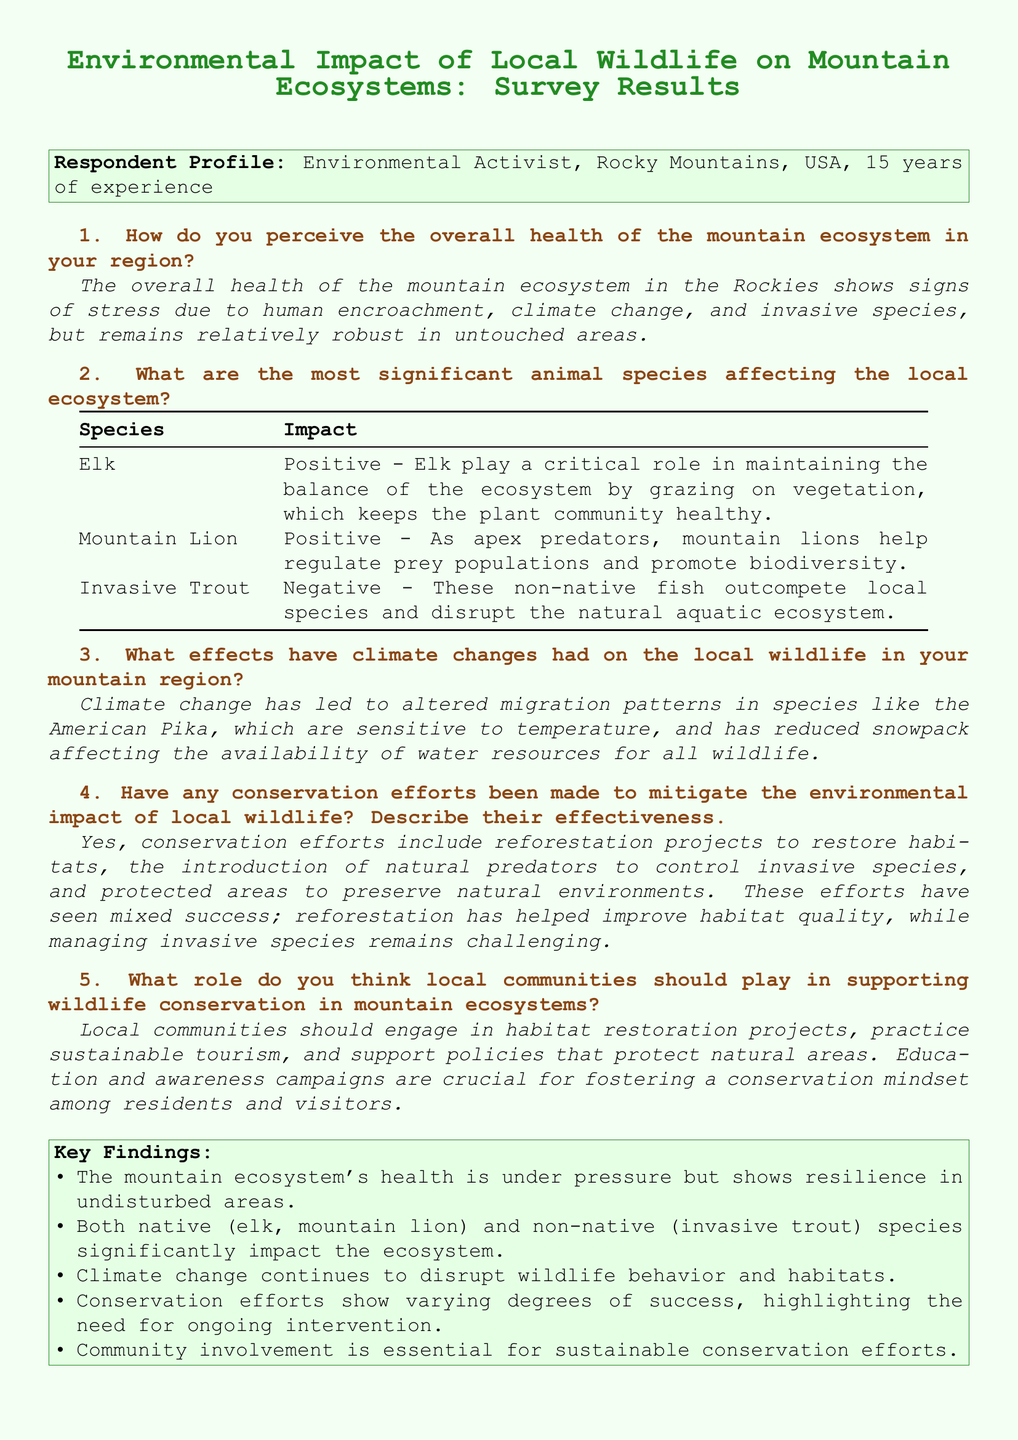what is the respondent's experience in environmental activism? The document states that the respondent has 15 years of experience in environmental activism.
Answer: 15 years what is the perceived overall health of the mountain ecosystem? The overall health is described as showing signs of stress due to various factors but remains relatively robust in untouched areas.
Answer: Signs of stress what are the two positive impacting species mentioned? The document lists elk and mountain lion as species that positively impact the local ecosystem.
Answer: Elk, mountain lion what negative impact is caused by invasive trout? Invasive trout are noted to disrupt the natural aquatic ecosystem and outcompete local species.
Answer: Disrupts the natural aquatic ecosystem which wildlife species is specifically mentioned to have altered migration patterns due to climate change? The American Pika is mentioned as a species affected by altered migration patterns from climate change.
Answer: American Pika what type of community involvement is emphasized for supporting wildlife conservation? The document emphasizes the importance of community engagement in habitat restoration projects as a form of support for wildlife conservation.
Answer: Habitat restoration projects how effective have conservation efforts been according to the survey results? The survey indicates that conservation efforts have seen mixed success, with some improvements and ongoing challenges.
Answer: Mixed success what is one method that has shown to improve habitat quality? Reforestation projects are identified as one method that has helped to improve habitat quality according to the survey findings.
Answer: Reforestation projects what is the main negative impact of climate change on local wildlife? The document states that climate change has led to reduced snowpack and altered migration patterns, primarily affecting water resources and wildlife behavior.
Answer: Reduced snowpack 